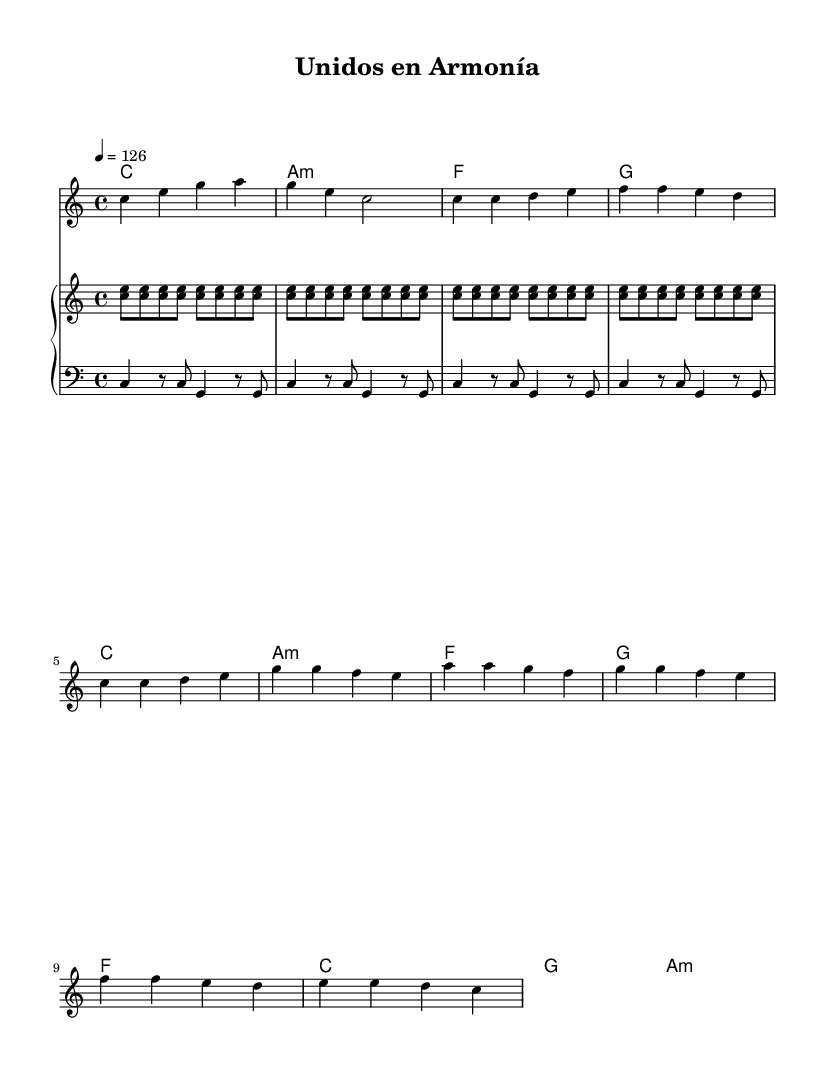What is the key signature of this music? The key signature is C major, indicated at the beginning of the score. C major has no sharps or flats.
Answer: C major What is the time signature of this piece? The time signature is 4/4, signifying four beats per measure, indicated at the beginning of the score.
Answer: 4/4 What is the tempo marking for this song? The tempo marking shows 4 equals 126, indicating the number of beats per minute.
Answer: 126 What is the first chord played in the song? The first chord is listed in the chord names section as C major, which appears at the start of the score.
Answer: C How many times is the chorus repeated? By analyzing the structure of the music, the chorus occurs once before the score concludes.
Answer: Once What genre is this music piece classified under? The style and rhythmic elements present within the sheet reflect traits of Latin pop music, indicated by the upbeat nature and cultural themes in the lyrics.
Answer: Latin pop What instrument is primarily indicated for the right-hand part? The right-hand part of the piano staff is labeled, and it contains a simplified salsa-inspired montuno pattern, which reinforces the Latin genre.
Answer: Piano 